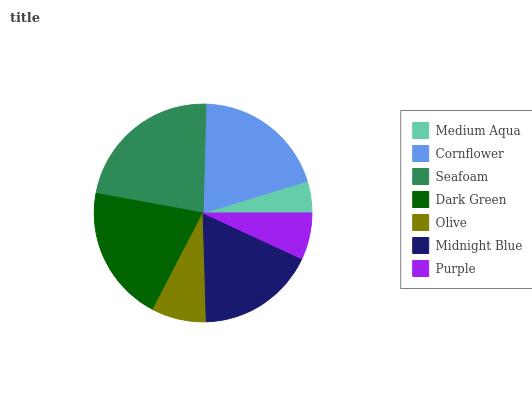Is Medium Aqua the minimum?
Answer yes or no. Yes. Is Seafoam the maximum?
Answer yes or no. Yes. Is Cornflower the minimum?
Answer yes or no. No. Is Cornflower the maximum?
Answer yes or no. No. Is Cornflower greater than Medium Aqua?
Answer yes or no. Yes. Is Medium Aqua less than Cornflower?
Answer yes or no. Yes. Is Medium Aqua greater than Cornflower?
Answer yes or no. No. Is Cornflower less than Medium Aqua?
Answer yes or no. No. Is Midnight Blue the high median?
Answer yes or no. Yes. Is Midnight Blue the low median?
Answer yes or no. Yes. Is Dark Green the high median?
Answer yes or no. No. Is Cornflower the low median?
Answer yes or no. No. 